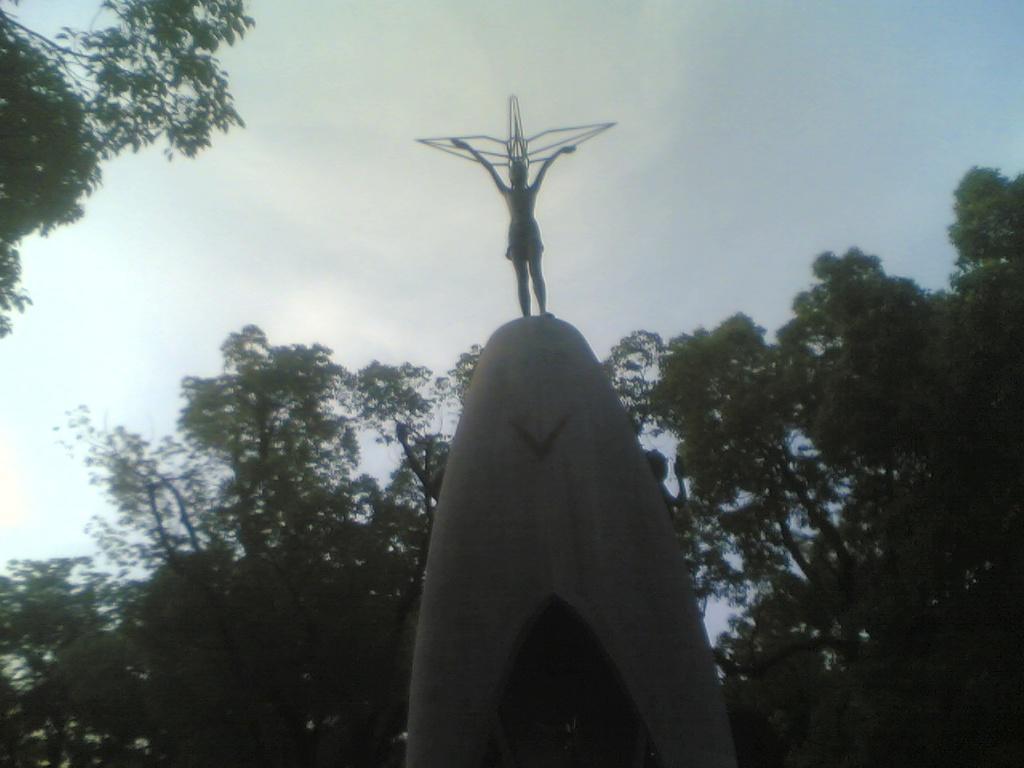Could you give a brief overview of what you see in this image? In this picture we can see the sky, trees. On the pedestal we can see the statue. 